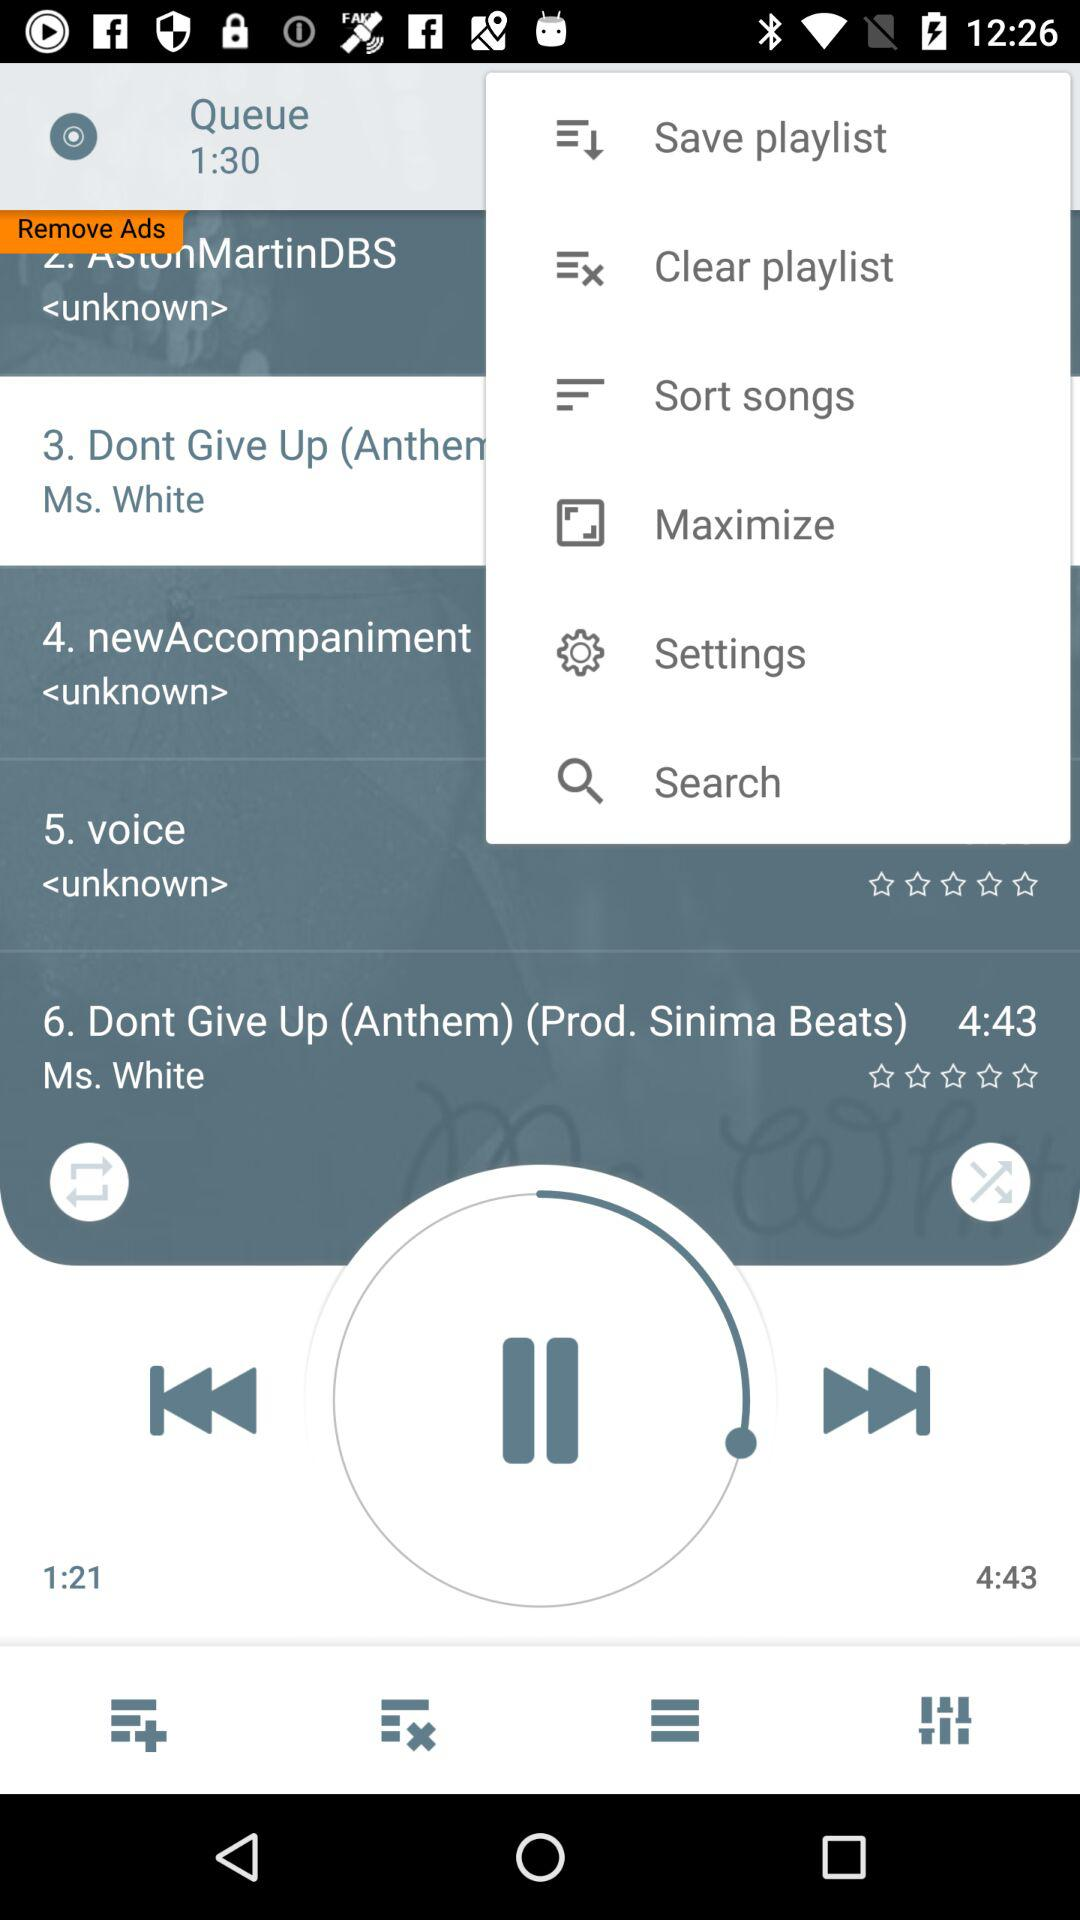How many stars showing in dont give up?
When the provided information is insufficient, respond with <no answer>. <no answer> 